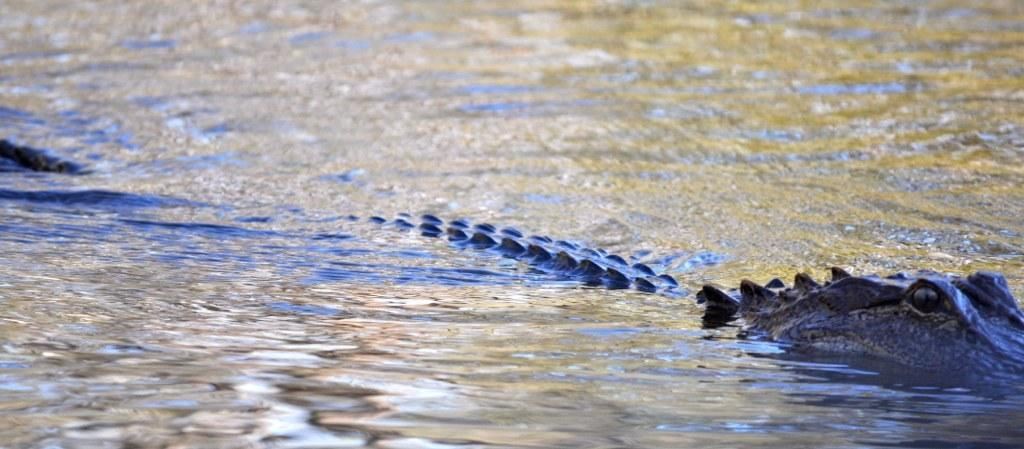What animal is present in the image? There is a crocodile in the image. Where is the crocodile located? The crocodile is in the water. What can be seen in the image besides the crocodile? There is water visible in the image. How would you describe the water in the image? The water appears to be flowing. What type of garden can be seen in the image? There is no garden present in the image; it features a crocodile in the water. What rule is being enforced by the crocodile in the image? There is no rule being enforced by the crocodile in the image; it is simply depicted in its natural habitat. 